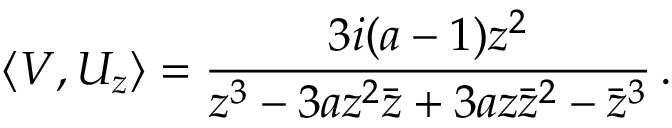Convert formula to latex. <formula><loc_0><loc_0><loc_500><loc_500>\langle V , U _ { z } \rangle = \frac { 3 i ( a - 1 ) z ^ { 2 } } { z ^ { 3 } - 3 a z ^ { 2 } { \bar { z } } + 3 a z { \bar { z } } ^ { 2 } - { \bar { z } } ^ { 3 } } \, .</formula> 